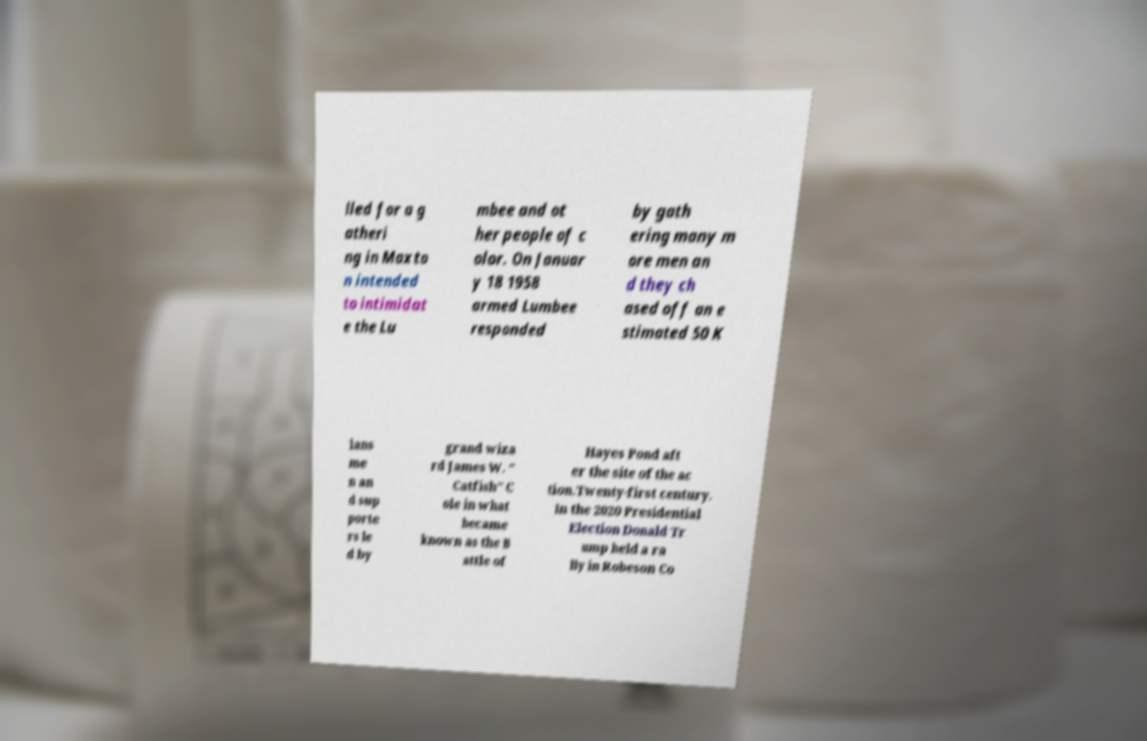I need the written content from this picture converted into text. Can you do that? lled for a g atheri ng in Maxto n intended to intimidat e the Lu mbee and ot her people of c olor. On Januar y 18 1958 armed Lumbee responded by gath ering many m ore men an d they ch ased off an e stimated 50 K lans me n an d sup porte rs le d by grand wiza rd James W. " Catfish" C ole in what became known as the B attle of Hayes Pond aft er the site of the ac tion.Twenty-first century. In the 2020 Presidential Election Donald Tr ump held a ra lly in Robeson Co 